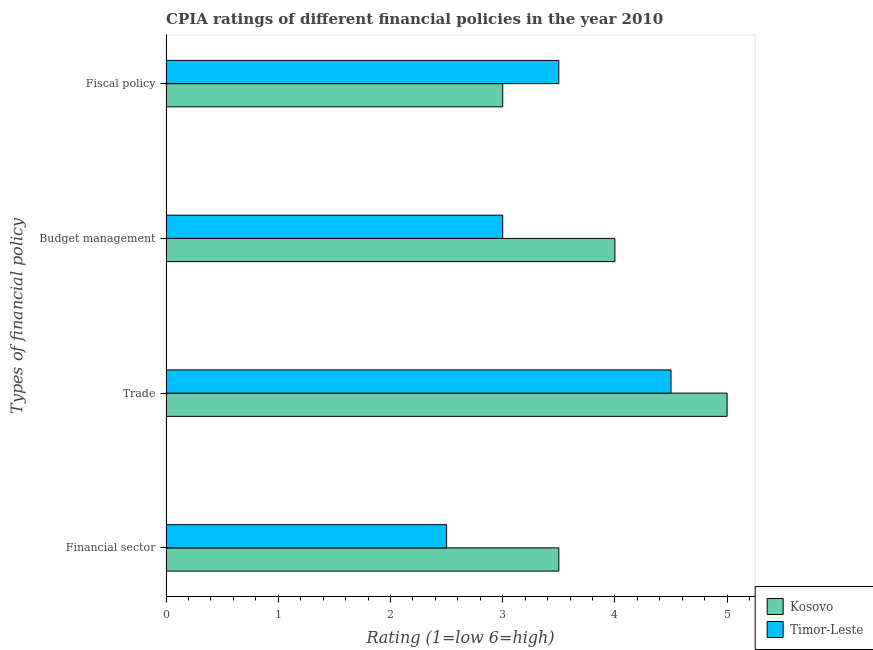Are the number of bars per tick equal to the number of legend labels?
Give a very brief answer. Yes. How many bars are there on the 3rd tick from the top?
Keep it short and to the point. 2. How many bars are there on the 2nd tick from the bottom?
Your answer should be compact. 2. What is the label of the 1st group of bars from the top?
Your answer should be compact. Fiscal policy. What is the cpia rating of trade in Timor-Leste?
Keep it short and to the point. 4.5. Across all countries, what is the maximum cpia rating of trade?
Make the answer very short. 5. Across all countries, what is the minimum cpia rating of fiscal policy?
Make the answer very short. 3. In which country was the cpia rating of budget management maximum?
Make the answer very short. Kosovo. In which country was the cpia rating of fiscal policy minimum?
Provide a short and direct response. Kosovo. What is the difference between the cpia rating of fiscal policy in Timor-Leste and that in Kosovo?
Your response must be concise. 0.5. What is the average cpia rating of budget management per country?
Make the answer very short. 3.5. In how many countries, is the cpia rating of trade greater than 3.6 ?
Make the answer very short. 2. What is the ratio of the cpia rating of financial sector in Kosovo to that in Timor-Leste?
Make the answer very short. 1.4. What is the difference between the highest and the lowest cpia rating of trade?
Your response must be concise. 0.5. What does the 1st bar from the top in Trade represents?
Ensure brevity in your answer.  Timor-Leste. What does the 2nd bar from the bottom in Budget management represents?
Your response must be concise. Timor-Leste. Is it the case that in every country, the sum of the cpia rating of financial sector and cpia rating of trade is greater than the cpia rating of budget management?
Give a very brief answer. Yes. How many bars are there?
Your answer should be very brief. 8. What is the difference between two consecutive major ticks on the X-axis?
Offer a terse response. 1. Does the graph contain any zero values?
Your response must be concise. No. Where does the legend appear in the graph?
Provide a succinct answer. Bottom right. What is the title of the graph?
Your answer should be very brief. CPIA ratings of different financial policies in the year 2010. Does "Panama" appear as one of the legend labels in the graph?
Ensure brevity in your answer.  No. What is the label or title of the Y-axis?
Give a very brief answer. Types of financial policy. What is the Rating (1=low 6=high) in Kosovo in Financial sector?
Make the answer very short. 3.5. What is the Rating (1=low 6=high) of Timor-Leste in Financial sector?
Your answer should be very brief. 2.5. What is the Rating (1=low 6=high) in Timor-Leste in Budget management?
Keep it short and to the point. 3. Across all Types of financial policy, what is the maximum Rating (1=low 6=high) of Kosovo?
Offer a terse response. 5. What is the total Rating (1=low 6=high) in Timor-Leste in the graph?
Your answer should be very brief. 13.5. What is the difference between the Rating (1=low 6=high) of Kosovo in Financial sector and that in Trade?
Your response must be concise. -1.5. What is the difference between the Rating (1=low 6=high) in Timor-Leste in Financial sector and that in Trade?
Provide a succinct answer. -2. What is the difference between the Rating (1=low 6=high) of Kosovo in Financial sector and that in Budget management?
Make the answer very short. -0.5. What is the difference between the Rating (1=low 6=high) in Timor-Leste in Financial sector and that in Budget management?
Your answer should be compact. -0.5. What is the difference between the Rating (1=low 6=high) of Timor-Leste in Financial sector and that in Fiscal policy?
Your answer should be very brief. -1. What is the difference between the Rating (1=low 6=high) in Kosovo in Trade and that in Budget management?
Give a very brief answer. 1. What is the difference between the Rating (1=low 6=high) in Timor-Leste in Trade and that in Budget management?
Offer a very short reply. 1.5. What is the difference between the Rating (1=low 6=high) of Kosovo in Trade and that in Fiscal policy?
Keep it short and to the point. 2. What is the difference between the Rating (1=low 6=high) in Kosovo in Budget management and that in Fiscal policy?
Ensure brevity in your answer.  1. What is the difference between the Rating (1=low 6=high) in Timor-Leste in Budget management and that in Fiscal policy?
Your answer should be compact. -0.5. What is the difference between the Rating (1=low 6=high) in Kosovo in Financial sector and the Rating (1=low 6=high) in Timor-Leste in Trade?
Provide a short and direct response. -1. What is the difference between the Rating (1=low 6=high) in Kosovo in Financial sector and the Rating (1=low 6=high) in Timor-Leste in Budget management?
Give a very brief answer. 0.5. What is the difference between the Rating (1=low 6=high) in Kosovo in Financial sector and the Rating (1=low 6=high) in Timor-Leste in Fiscal policy?
Provide a short and direct response. 0. What is the average Rating (1=low 6=high) in Kosovo per Types of financial policy?
Give a very brief answer. 3.88. What is the average Rating (1=low 6=high) in Timor-Leste per Types of financial policy?
Make the answer very short. 3.38. What is the difference between the Rating (1=low 6=high) of Kosovo and Rating (1=low 6=high) of Timor-Leste in Financial sector?
Provide a succinct answer. 1. What is the difference between the Rating (1=low 6=high) in Kosovo and Rating (1=low 6=high) in Timor-Leste in Trade?
Your answer should be very brief. 0.5. What is the difference between the Rating (1=low 6=high) of Kosovo and Rating (1=low 6=high) of Timor-Leste in Budget management?
Give a very brief answer. 1. What is the ratio of the Rating (1=low 6=high) of Kosovo in Financial sector to that in Trade?
Provide a short and direct response. 0.7. What is the ratio of the Rating (1=low 6=high) in Timor-Leste in Financial sector to that in Trade?
Provide a short and direct response. 0.56. What is the ratio of the Rating (1=low 6=high) of Timor-Leste in Financial sector to that in Fiscal policy?
Keep it short and to the point. 0.71. What is the ratio of the Rating (1=low 6=high) in Timor-Leste in Trade to that in Budget management?
Give a very brief answer. 1.5. What is the ratio of the Rating (1=low 6=high) of Timor-Leste in Trade to that in Fiscal policy?
Provide a short and direct response. 1.29. What is the ratio of the Rating (1=low 6=high) in Kosovo in Budget management to that in Fiscal policy?
Offer a terse response. 1.33. What is the ratio of the Rating (1=low 6=high) of Timor-Leste in Budget management to that in Fiscal policy?
Ensure brevity in your answer.  0.86. What is the difference between the highest and the second highest Rating (1=low 6=high) in Timor-Leste?
Offer a very short reply. 1. What is the difference between the highest and the lowest Rating (1=low 6=high) in Kosovo?
Your response must be concise. 2. What is the difference between the highest and the lowest Rating (1=low 6=high) of Timor-Leste?
Your answer should be compact. 2. 